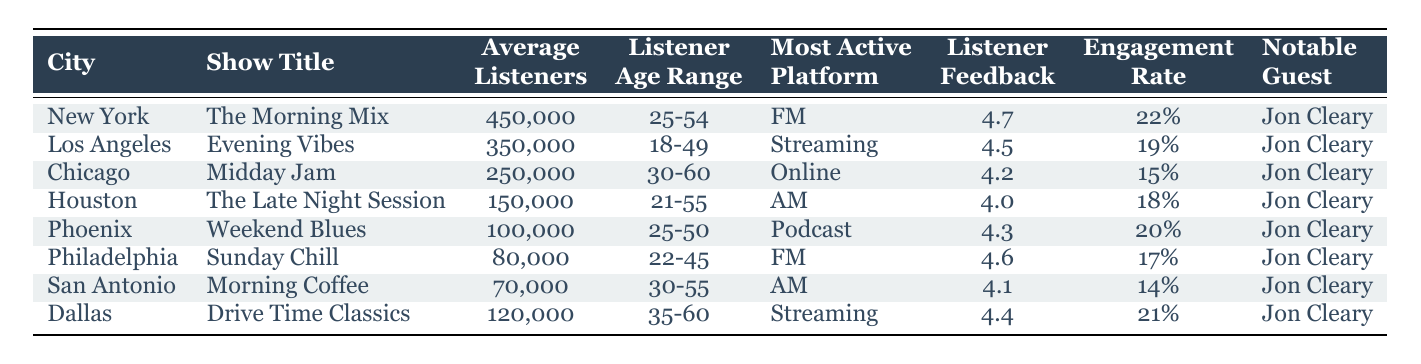What is the average number of listeners for the show in New York? The table shows that "The Morning Mix" has an average of 450,000 listeners in New York. This value is found directly in the relevant row of the table.
Answer: 450000 Which city has the highest listener feedback rating? From the table, New York's "The Morning Mix" has the highest listener feedback rating of 4.7, which is greater than all other listed ratings.
Answer: New York What is the engagement rate for the show in Chicago? The engagement rate for "Midday Jam" in Chicago is provided in the table and is 0.15. This is found directly in the row for Chicago.
Answer: 0.15 Is the most active platform for listeners in Los Angeles "Streaming"? According to the table, the most active platform for "Evening Vibes" in Los Angeles is indeed "Streaming." The data is explicitly indicated in the relevant row.
Answer: Yes What is the total average number of listeners across all shows? To find the total, we sum the average listeners for all cities: 450,000 (New York) + 350,000 (Los Angeles) + 250,000 (Chicago) + 150,000 (Houston) + 100,000 (Phoenix) + 80,000 (Philadelphia) + 70,000 (San Antonio) + 120,000 (Dallas) = 1,620,000. The total is divided by 8 (the number of cities) giving an average of 202,500.
Answer: 202500 For which city is the notable guest "Jon Cleary" featured in the least popular show based on average listeners? By examining the average listeners, "Morning Coffee" in San Antonio has 70,000 listeners, which is the lowest when compared to other shows. The notable guest for this show is Jon Cleary, making San Antonio the answer.
Answer: San Antonio 